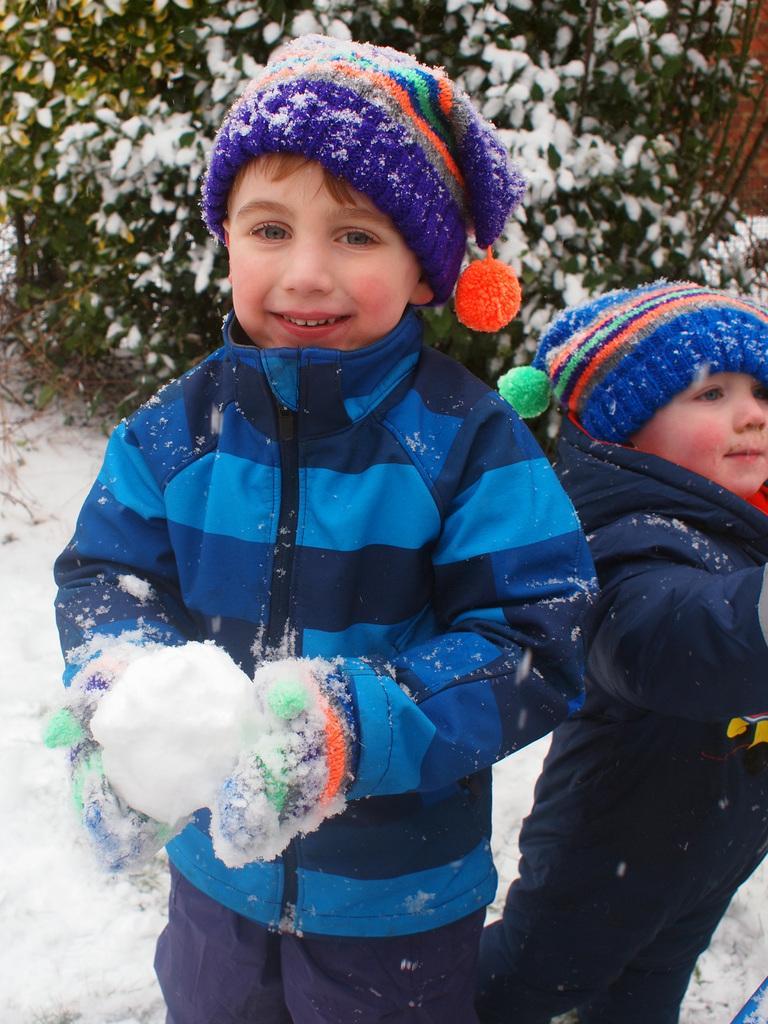How would you summarize this image in a sentence or two? In this image we can see two children. They are wearing caps. Also there is snow. In the back there are plants with snow. 